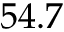<formula> <loc_0><loc_0><loc_500><loc_500>5 4 . 7</formula> 